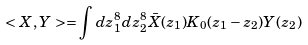<formula> <loc_0><loc_0><loc_500><loc_500>< X , Y > = \int d z _ { 1 } ^ { 8 } d z _ { 2 } ^ { 8 } \bar { X } ( z _ { 1 } ) K _ { 0 } ( z _ { 1 } - z _ { 2 } ) Y ( z _ { 2 } )</formula> 